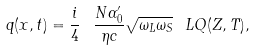<formula> <loc_0><loc_0><loc_500><loc_500>q ( x , t ) = \frac { i } { 4 } \ \frac { N \alpha _ { 0 } ^ { \prime } } { \eta c } \sqrt { \omega _ { L } \omega _ { S } } \ L Q ( Z , T ) ,</formula> 